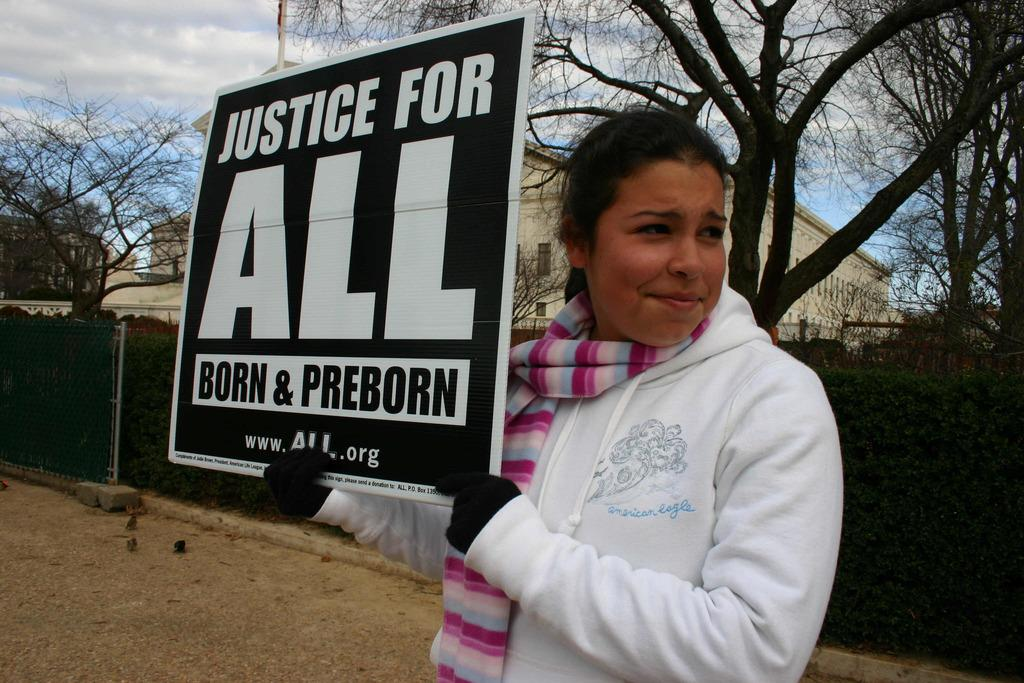What is the person in the image doing? The person is standing and holding a board in the image. What can be seen in the background of the image? There are plants, a wire fence, buildings, trees, a pole, and the sky visible in the background of the image. What type of bag can be seen hanging from the pole in the image? There is no bag hanging from the pole in the image; only the pole is visible in the background. 